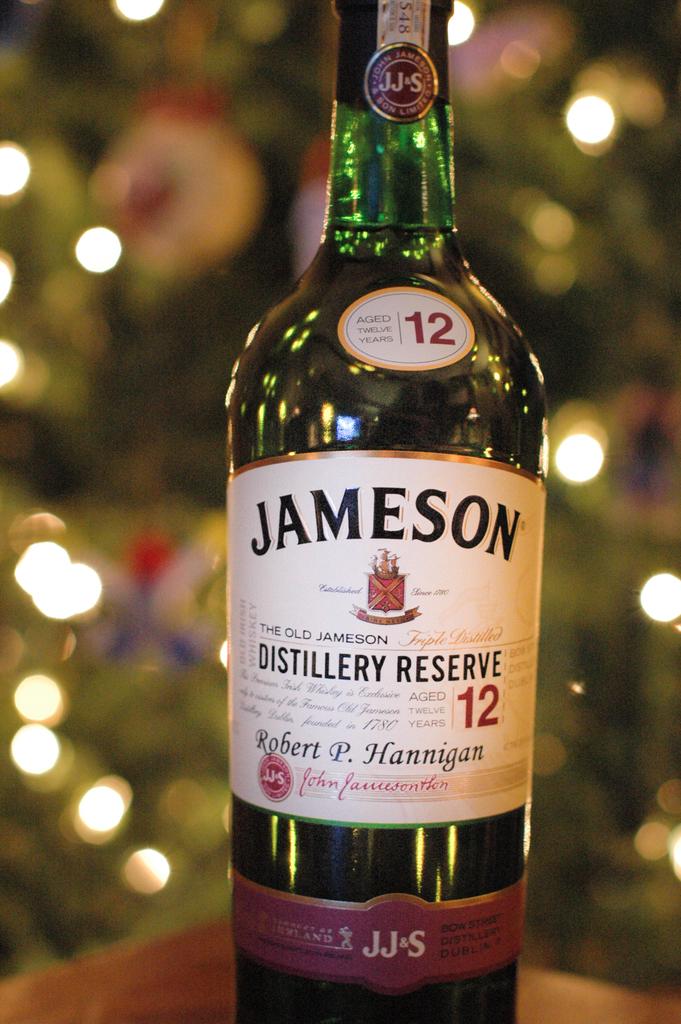How many years was this bottle  of alcohol aged?
Your answer should be compact. 12. 